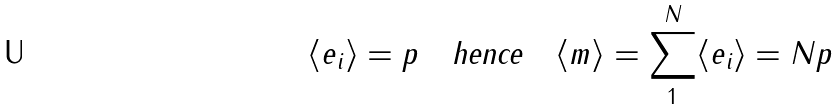Convert formula to latex. <formula><loc_0><loc_0><loc_500><loc_500>\langle e _ { i } \rangle = p \quad \text {hence} \quad \langle m \rangle = \sum _ { 1 } ^ { N } \langle e _ { i } \rangle = N p</formula> 